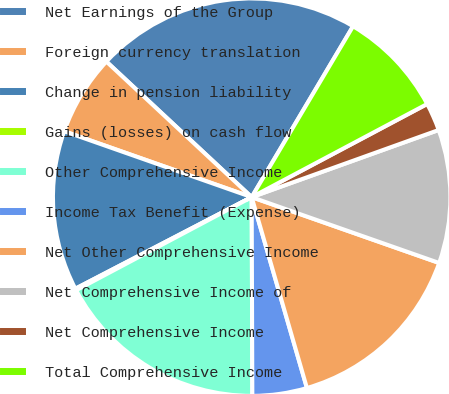<chart> <loc_0><loc_0><loc_500><loc_500><pie_chart><fcel>Net Earnings of the Group<fcel>Foreign currency translation<fcel>Change in pension liability<fcel>Gains (losses) on cash flow<fcel>Other Comprehensive Income<fcel>Income Tax Benefit (Expense)<fcel>Net Other Comprehensive Income<fcel>Net Comprehensive Income of<fcel>Net Comprehensive Income<fcel>Total Comprehensive Income<nl><fcel>21.57%<fcel>6.57%<fcel>13.0%<fcel>0.14%<fcel>17.29%<fcel>4.43%<fcel>15.14%<fcel>10.86%<fcel>2.28%<fcel>8.71%<nl></chart> 